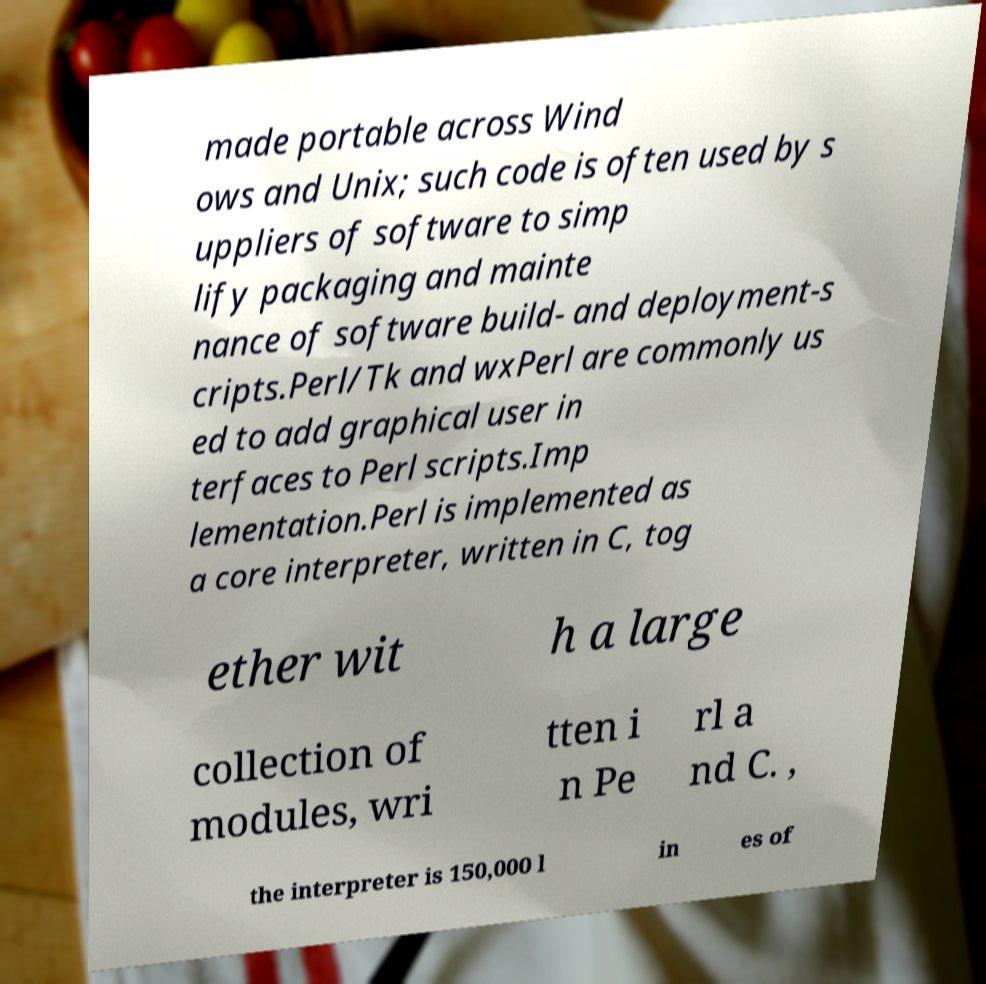Could you assist in decoding the text presented in this image and type it out clearly? made portable across Wind ows and Unix; such code is often used by s uppliers of software to simp lify packaging and mainte nance of software build- and deployment-s cripts.Perl/Tk and wxPerl are commonly us ed to add graphical user in terfaces to Perl scripts.Imp lementation.Perl is implemented as a core interpreter, written in C, tog ether wit h a large collection of modules, wri tten i n Pe rl a nd C. , the interpreter is 150,000 l in es of 